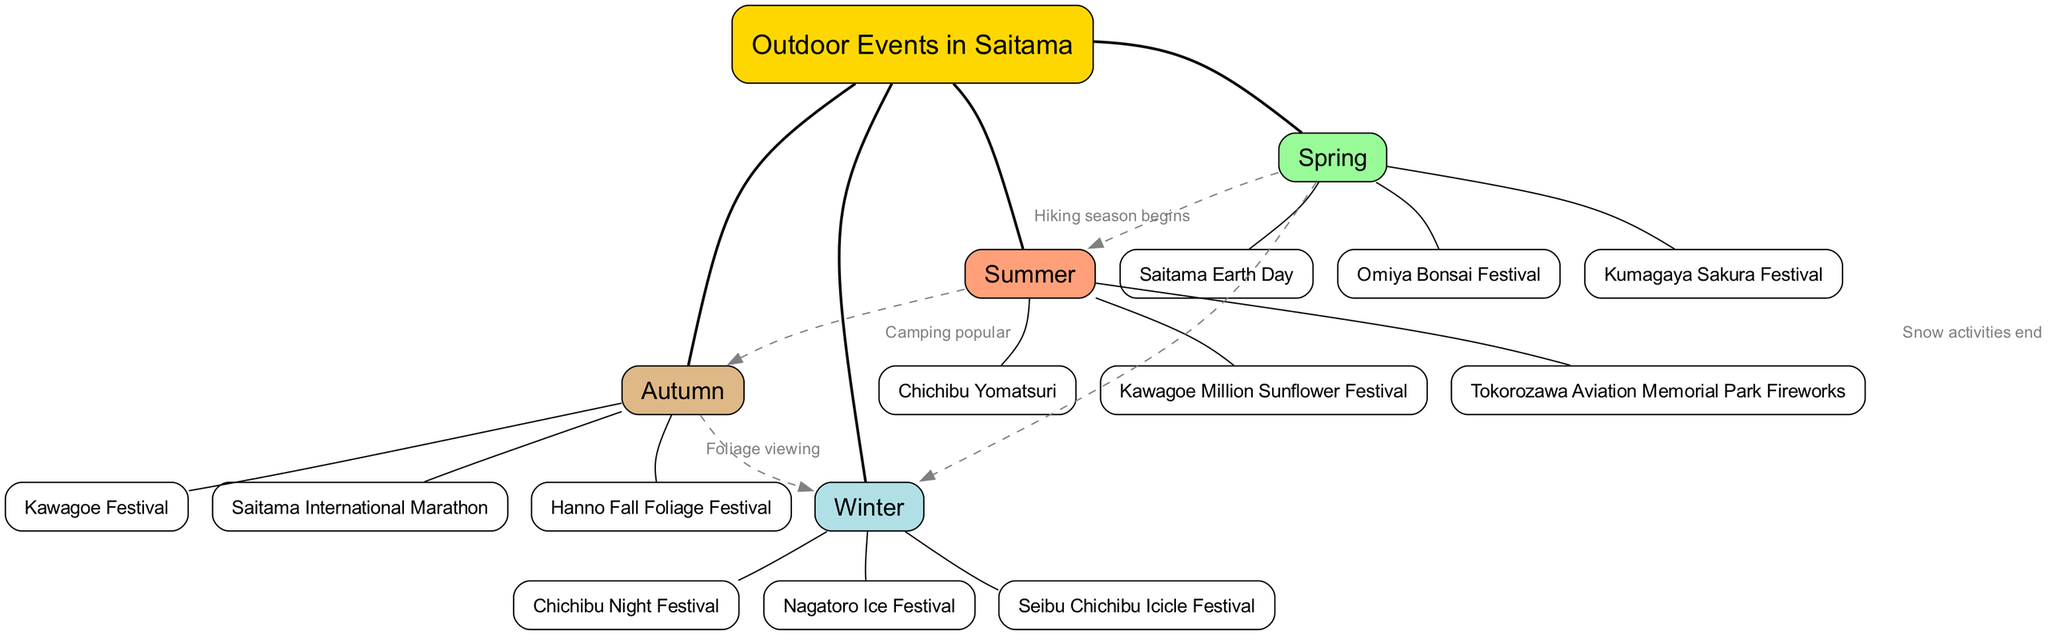What events are listed under Spring? The diagram shows three events under the Spring branch: Omiya Bonsai Festival, Kumagaya Sakura Festival, and Saitama Earth Day.
Answer: Omiya Bonsai Festival, Kumagaya Sakura Festival, Saitama Earth Day How many main branches are there in the diagram? The diagram outlines four main branches: Spring, Summer, Autumn, and Winter. Therefore, the total count is four.
Answer: 4 Which event is associated with Summer? Under the Summer branch, the events listed are Chichibu Yomatsuri, Kawagoe Million Sunflower Festival, and Tokorozawa Aviation Memorial Park Fireworks. Therefore, any one of these is correct.
Answer: Chichibu Yomatsuri (or any summer event) What is the label of the connection from Autumn to Winter? The connection from Autumn to Winter is labeled "Foliage viewing." This indicates a transition or seasonal relationship between these two branches.
Answer: Foliage viewing What happens to snow activities as Winter transitions to Spring? As indicated in the diagram, when Winter transitions to Spring, the label states "Snow activities end," showing the cycle of seasonal activities.
Answer: Snow activities end Which season features the Nagatoro Ice Festival? The Nagatoro Ice Festival is featured under the Winter season, as identified in the Winter section of the diagram.
Answer: Winter How does Spring connect to Summer? The connection between Spring and Summer is labeled "Hiking season begins," illustrating a seasonal activity that begins during this transition.
Answer: Hiking season begins In which season is the Saitama International Marathon held? The Saitama International Marathon is listed under the Autumn season according to the events shown in the Autumn branch of the diagram.
Answer: Autumn What color represents the Summer branch in the diagram? The Summer branch in the diagram is represented by a light coral color, specified in the color palette details for the seasons.
Answer: #FFA07A 